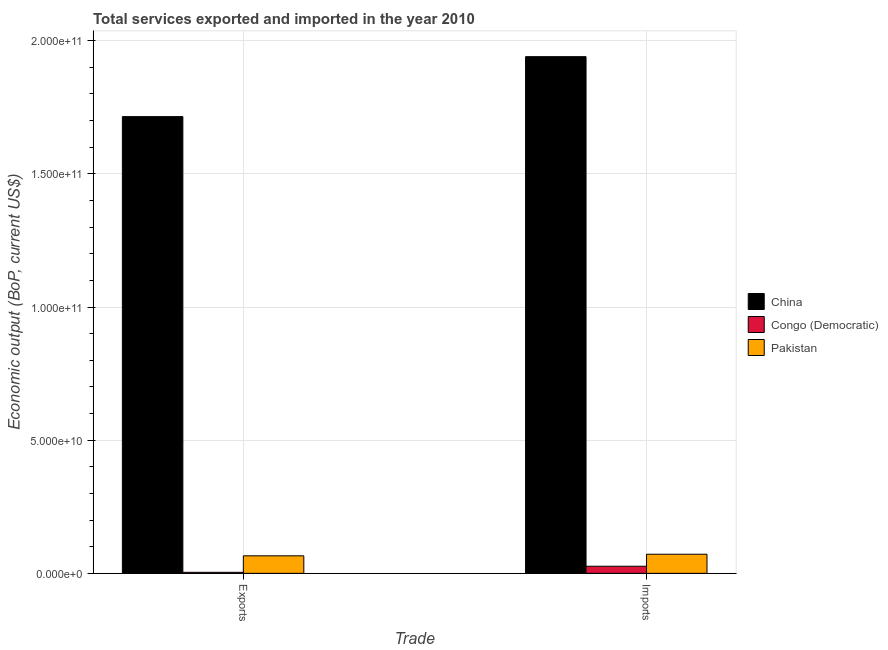How many different coloured bars are there?
Offer a terse response. 3. How many groups of bars are there?
Your response must be concise. 2. Are the number of bars per tick equal to the number of legend labels?
Offer a very short reply. Yes. What is the label of the 1st group of bars from the left?
Ensure brevity in your answer.  Exports. What is the amount of service exports in Pakistan?
Offer a terse response. 6.58e+09. Across all countries, what is the maximum amount of service exports?
Provide a succinct answer. 1.71e+11. Across all countries, what is the minimum amount of service imports?
Ensure brevity in your answer.  2.66e+09. In which country was the amount of service exports maximum?
Your answer should be very brief. China. In which country was the amount of service exports minimum?
Ensure brevity in your answer.  Congo (Democratic). What is the total amount of service exports in the graph?
Keep it short and to the point. 1.78e+11. What is the difference between the amount of service imports in Pakistan and that in China?
Provide a short and direct response. -1.87e+11. What is the difference between the amount of service exports in Pakistan and the amount of service imports in Congo (Democratic)?
Your answer should be compact. 3.91e+09. What is the average amount of service exports per country?
Offer a very short reply. 5.95e+1. What is the difference between the amount of service exports and amount of service imports in China?
Provide a succinct answer. -2.25e+1. What is the ratio of the amount of service exports in Congo (Democratic) to that in China?
Provide a succinct answer. 0. In how many countries, is the amount of service exports greater than the average amount of service exports taken over all countries?
Offer a very short reply. 1. What does the 2nd bar from the right in Exports represents?
Your answer should be very brief. Congo (Democratic). How many countries are there in the graph?
Offer a terse response. 3. What is the difference between two consecutive major ticks on the Y-axis?
Provide a short and direct response. 5.00e+1. Are the values on the major ticks of Y-axis written in scientific E-notation?
Offer a very short reply. Yes. Does the graph contain any zero values?
Offer a terse response. No. Does the graph contain grids?
Give a very brief answer. Yes. Where does the legend appear in the graph?
Make the answer very short. Center right. How are the legend labels stacked?
Provide a short and direct response. Vertical. What is the title of the graph?
Provide a succinct answer. Total services exported and imported in the year 2010. What is the label or title of the X-axis?
Keep it short and to the point. Trade. What is the label or title of the Y-axis?
Provide a short and direct response. Economic output (BoP, current US$). What is the Economic output (BoP, current US$) in China in Exports?
Make the answer very short. 1.71e+11. What is the Economic output (BoP, current US$) in Congo (Democratic) in Exports?
Your response must be concise. 3.89e+08. What is the Economic output (BoP, current US$) of Pakistan in Exports?
Offer a terse response. 6.58e+09. What is the Economic output (BoP, current US$) in China in Imports?
Your response must be concise. 1.94e+11. What is the Economic output (BoP, current US$) of Congo (Democratic) in Imports?
Give a very brief answer. 2.66e+09. What is the Economic output (BoP, current US$) of Pakistan in Imports?
Offer a terse response. 7.18e+09. Across all Trade, what is the maximum Economic output (BoP, current US$) of China?
Your answer should be compact. 1.94e+11. Across all Trade, what is the maximum Economic output (BoP, current US$) in Congo (Democratic)?
Offer a very short reply. 2.66e+09. Across all Trade, what is the maximum Economic output (BoP, current US$) in Pakistan?
Offer a terse response. 7.18e+09. Across all Trade, what is the minimum Economic output (BoP, current US$) of China?
Your answer should be very brief. 1.71e+11. Across all Trade, what is the minimum Economic output (BoP, current US$) in Congo (Democratic)?
Offer a very short reply. 3.89e+08. Across all Trade, what is the minimum Economic output (BoP, current US$) of Pakistan?
Ensure brevity in your answer.  6.58e+09. What is the total Economic output (BoP, current US$) of China in the graph?
Provide a succinct answer. 3.65e+11. What is the total Economic output (BoP, current US$) of Congo (Democratic) in the graph?
Your answer should be very brief. 3.05e+09. What is the total Economic output (BoP, current US$) in Pakistan in the graph?
Offer a terse response. 1.38e+1. What is the difference between the Economic output (BoP, current US$) in China in Exports and that in Imports?
Ensure brevity in your answer.  -2.25e+1. What is the difference between the Economic output (BoP, current US$) of Congo (Democratic) in Exports and that in Imports?
Provide a succinct answer. -2.27e+09. What is the difference between the Economic output (BoP, current US$) of Pakistan in Exports and that in Imports?
Your response must be concise. -6.00e+08. What is the difference between the Economic output (BoP, current US$) in China in Exports and the Economic output (BoP, current US$) in Congo (Democratic) in Imports?
Your answer should be compact. 1.69e+11. What is the difference between the Economic output (BoP, current US$) of China in Exports and the Economic output (BoP, current US$) of Pakistan in Imports?
Provide a succinct answer. 1.64e+11. What is the difference between the Economic output (BoP, current US$) in Congo (Democratic) in Exports and the Economic output (BoP, current US$) in Pakistan in Imports?
Make the answer very short. -6.79e+09. What is the average Economic output (BoP, current US$) in China per Trade?
Offer a very short reply. 1.83e+11. What is the average Economic output (BoP, current US$) of Congo (Democratic) per Trade?
Give a very brief answer. 1.53e+09. What is the average Economic output (BoP, current US$) in Pakistan per Trade?
Give a very brief answer. 6.88e+09. What is the difference between the Economic output (BoP, current US$) of China and Economic output (BoP, current US$) of Congo (Democratic) in Exports?
Offer a terse response. 1.71e+11. What is the difference between the Economic output (BoP, current US$) in China and Economic output (BoP, current US$) in Pakistan in Exports?
Ensure brevity in your answer.  1.65e+11. What is the difference between the Economic output (BoP, current US$) of Congo (Democratic) and Economic output (BoP, current US$) of Pakistan in Exports?
Make the answer very short. -6.19e+09. What is the difference between the Economic output (BoP, current US$) of China and Economic output (BoP, current US$) of Congo (Democratic) in Imports?
Your response must be concise. 1.91e+11. What is the difference between the Economic output (BoP, current US$) of China and Economic output (BoP, current US$) of Pakistan in Imports?
Offer a very short reply. 1.87e+11. What is the difference between the Economic output (BoP, current US$) of Congo (Democratic) and Economic output (BoP, current US$) of Pakistan in Imports?
Your answer should be compact. -4.51e+09. What is the ratio of the Economic output (BoP, current US$) of China in Exports to that in Imports?
Your answer should be compact. 0.88. What is the ratio of the Economic output (BoP, current US$) of Congo (Democratic) in Exports to that in Imports?
Provide a succinct answer. 0.15. What is the ratio of the Economic output (BoP, current US$) in Pakistan in Exports to that in Imports?
Keep it short and to the point. 0.92. What is the difference between the highest and the second highest Economic output (BoP, current US$) of China?
Your answer should be compact. 2.25e+1. What is the difference between the highest and the second highest Economic output (BoP, current US$) of Congo (Democratic)?
Offer a terse response. 2.27e+09. What is the difference between the highest and the second highest Economic output (BoP, current US$) of Pakistan?
Your answer should be compact. 6.00e+08. What is the difference between the highest and the lowest Economic output (BoP, current US$) in China?
Ensure brevity in your answer.  2.25e+1. What is the difference between the highest and the lowest Economic output (BoP, current US$) in Congo (Democratic)?
Provide a succinct answer. 2.27e+09. What is the difference between the highest and the lowest Economic output (BoP, current US$) of Pakistan?
Offer a terse response. 6.00e+08. 